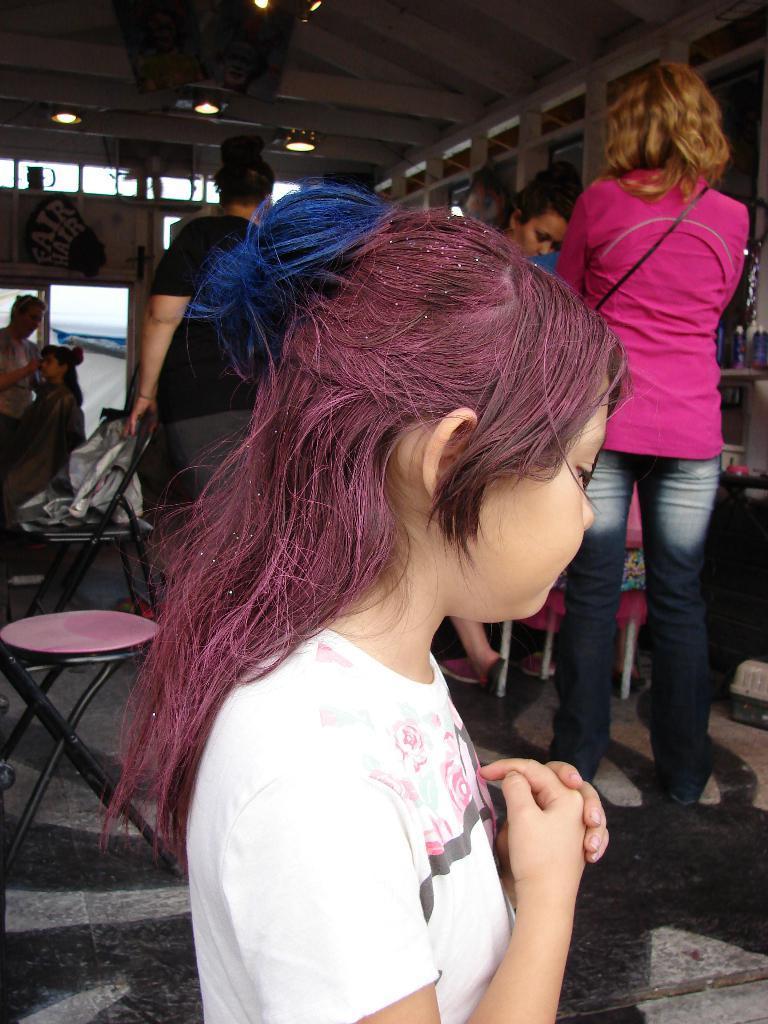Describe this image in one or two sentences. Here we can see people, chairs and lights. On this table there are objects. 